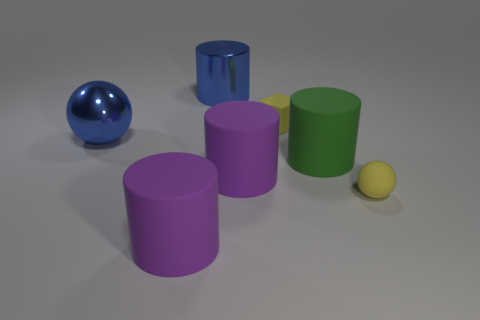Is the matte block the same color as the rubber sphere?
Your answer should be compact. Yes. Is the material of the small sphere the same as the blue object left of the big blue metal cylinder?
Make the answer very short. No. Does the tiny ball have the same color as the tiny object that is behind the big ball?
Your answer should be compact. Yes. The thing that is both behind the big metal sphere and to the left of the rubber cube is made of what material?
Make the answer very short. Metal. How many other large matte objects are the same shape as the green matte object?
Your answer should be compact. 2. What number of things are large matte objects left of the green object or rubber things?
Offer a terse response. 5. The purple rubber thing that is in front of the small yellow thing that is in front of the matte thing that is behind the blue ball is what shape?
Offer a very short reply. Cylinder. The yellow thing that is the same material as the tiny cube is what shape?
Keep it short and to the point. Sphere. What size is the blue cylinder?
Provide a succinct answer. Large. Do the metallic ball and the matte cube have the same size?
Your answer should be compact. No. 